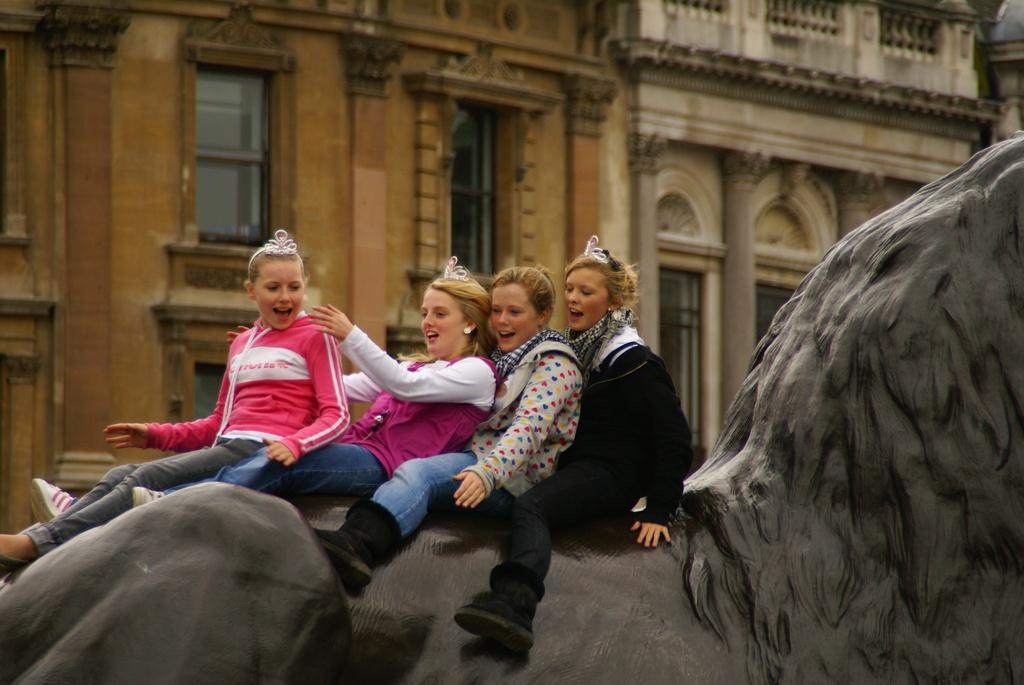How many people are in the image? There are four women in the image. What are the women doing in the image? The women are sitting on a black statue. What expression do the women have in the image? The women are smiling. What type of jelly can be seen in the image? There is no jelly present in the image. Is there a hole in the statue that the women are sitting on? The provided facts do not mention any holes in the statue. 